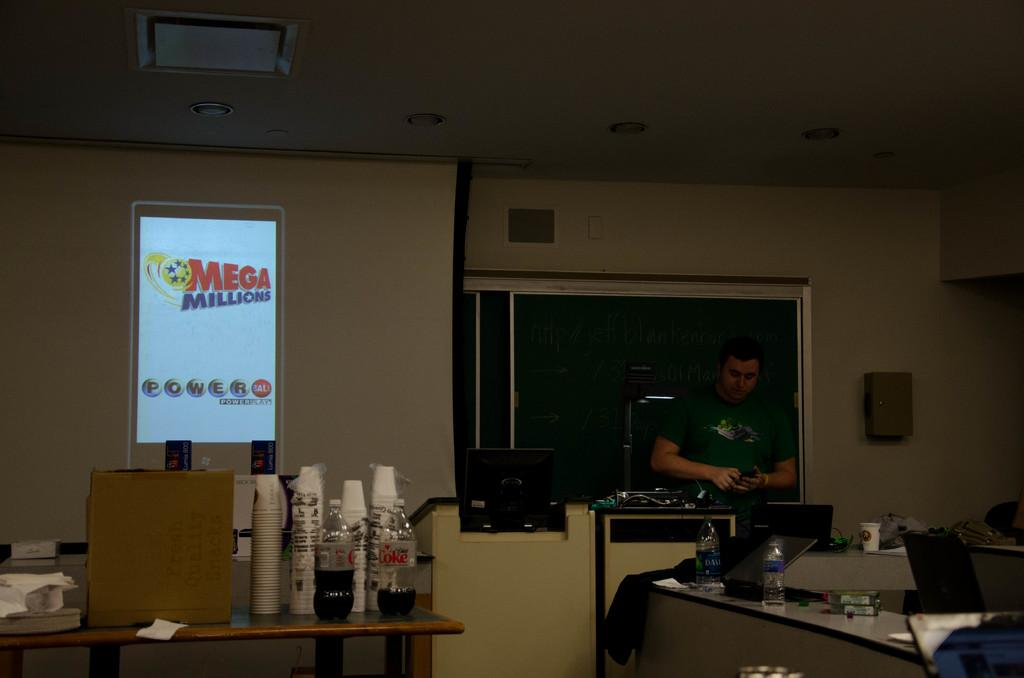<image>
Share a concise interpretation of the image provided. A projector screen shows the logo for the Mega Millions Powerball. 